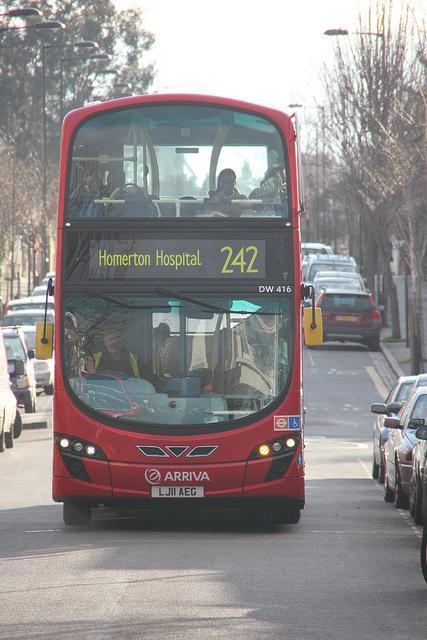How many cars are there?
Give a very brief answer. 2. 